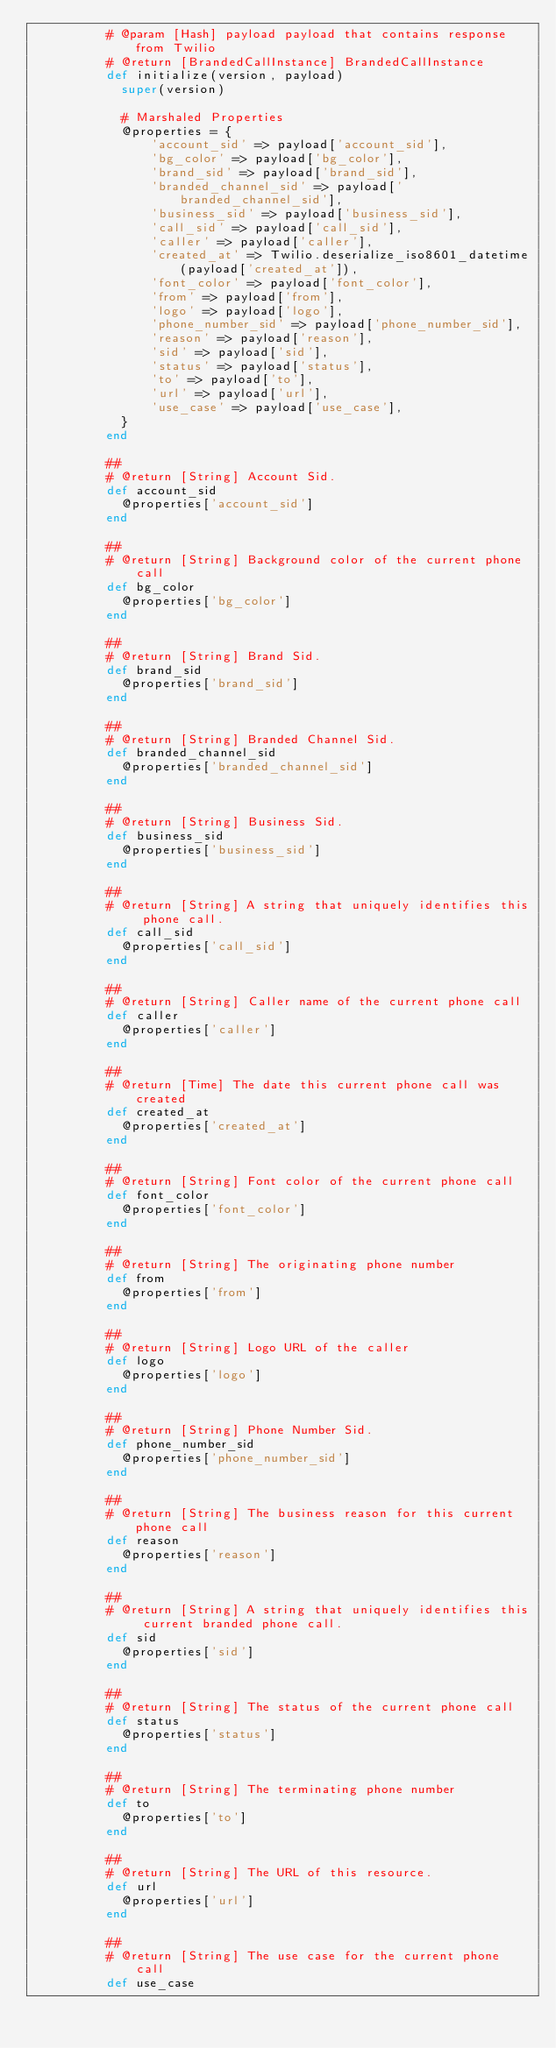Convert code to text. <code><loc_0><loc_0><loc_500><loc_500><_Ruby_>          # @param [Hash] payload payload that contains response from Twilio
          # @return [BrandedCallInstance] BrandedCallInstance
          def initialize(version, payload)
            super(version)

            # Marshaled Properties
            @properties = {
                'account_sid' => payload['account_sid'],
                'bg_color' => payload['bg_color'],
                'brand_sid' => payload['brand_sid'],
                'branded_channel_sid' => payload['branded_channel_sid'],
                'business_sid' => payload['business_sid'],
                'call_sid' => payload['call_sid'],
                'caller' => payload['caller'],
                'created_at' => Twilio.deserialize_iso8601_datetime(payload['created_at']),
                'font_color' => payload['font_color'],
                'from' => payload['from'],
                'logo' => payload['logo'],
                'phone_number_sid' => payload['phone_number_sid'],
                'reason' => payload['reason'],
                'sid' => payload['sid'],
                'status' => payload['status'],
                'to' => payload['to'],
                'url' => payload['url'],
                'use_case' => payload['use_case'],
            }
          end

          ##
          # @return [String] Account Sid.
          def account_sid
            @properties['account_sid']
          end

          ##
          # @return [String] Background color of the current phone call
          def bg_color
            @properties['bg_color']
          end

          ##
          # @return [String] Brand Sid.
          def brand_sid
            @properties['brand_sid']
          end

          ##
          # @return [String] Branded Channel Sid.
          def branded_channel_sid
            @properties['branded_channel_sid']
          end

          ##
          # @return [String] Business Sid.
          def business_sid
            @properties['business_sid']
          end

          ##
          # @return [String] A string that uniquely identifies this phone call.
          def call_sid
            @properties['call_sid']
          end

          ##
          # @return [String] Caller name of the current phone call
          def caller
            @properties['caller']
          end

          ##
          # @return [Time] The date this current phone call was created
          def created_at
            @properties['created_at']
          end

          ##
          # @return [String] Font color of the current phone call
          def font_color
            @properties['font_color']
          end

          ##
          # @return [String] The originating phone number
          def from
            @properties['from']
          end

          ##
          # @return [String] Logo URL of the caller
          def logo
            @properties['logo']
          end

          ##
          # @return [String] Phone Number Sid.
          def phone_number_sid
            @properties['phone_number_sid']
          end

          ##
          # @return [String] The business reason for this current phone call
          def reason
            @properties['reason']
          end

          ##
          # @return [String] A string that uniquely identifies this current branded phone call.
          def sid
            @properties['sid']
          end

          ##
          # @return [String] The status of the current phone call
          def status
            @properties['status']
          end

          ##
          # @return [String] The terminating phone number
          def to
            @properties['to']
          end

          ##
          # @return [String] The URL of this resource.
          def url
            @properties['url']
          end

          ##
          # @return [String] The use case for the current phone call
          def use_case</code> 